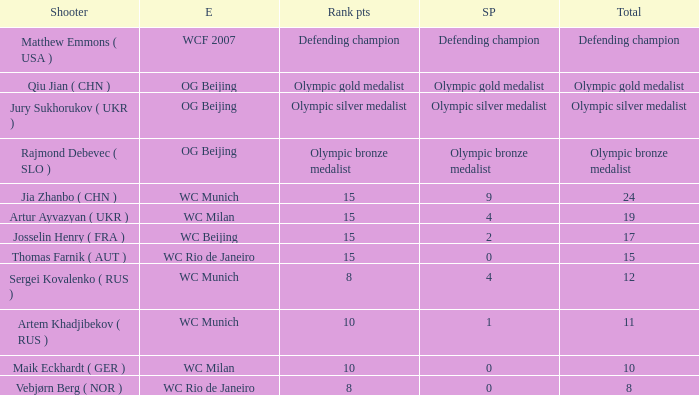With Olympic Bronze Medalist as the total what are the score points? Olympic bronze medalist. Can you give me this table as a dict? {'header': ['Shooter', 'E', 'Rank pts', 'SP', 'Total'], 'rows': [['Matthew Emmons ( USA )', 'WCF 2007', 'Defending champion', 'Defending champion', 'Defending champion'], ['Qiu Jian ( CHN )', 'OG Beijing', 'Olympic gold medalist', 'Olympic gold medalist', 'Olympic gold medalist'], ['Jury Sukhorukov ( UKR )', 'OG Beijing', 'Olympic silver medalist', 'Olympic silver medalist', 'Olympic silver medalist'], ['Rajmond Debevec ( SLO )', 'OG Beijing', 'Olympic bronze medalist', 'Olympic bronze medalist', 'Olympic bronze medalist'], ['Jia Zhanbo ( CHN )', 'WC Munich', '15', '9', '24'], ['Artur Ayvazyan ( UKR )', 'WC Milan', '15', '4', '19'], ['Josselin Henry ( FRA )', 'WC Beijing', '15', '2', '17'], ['Thomas Farnik ( AUT )', 'WC Rio de Janeiro', '15', '0', '15'], ['Sergei Kovalenko ( RUS )', 'WC Munich', '8', '4', '12'], ['Artem Khadjibekov ( RUS )', 'WC Munich', '10', '1', '11'], ['Maik Eckhardt ( GER )', 'WC Milan', '10', '0', '10'], ['Vebjørn Berg ( NOR )', 'WC Rio de Janeiro', '8', '0', '8']]} 